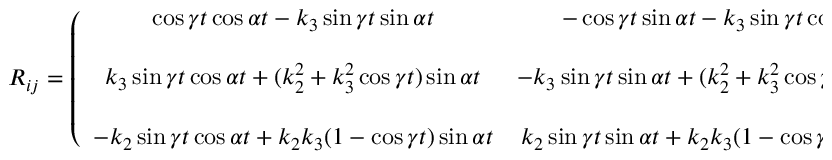<formula> <loc_0><loc_0><loc_500><loc_500>\begin{array} { r } { R _ { i j } = \left ( \begin{array} { c c c } { \cos \gamma t \cos \alpha t - k _ { 3 } \sin \gamma t \sin \alpha t } & { - \cos \gamma t \sin \alpha t - k _ { 3 } \sin \gamma t \cos \alpha t } & { k _ { 2 } \sin \gamma t } \\ { k _ { 3 } \sin \gamma t \cos \alpha t + ( k _ { 2 } ^ { 2 } + k _ { 3 } ^ { 2 } \cos \gamma t ) \sin \alpha t } & { - k _ { 3 } \sin \gamma t \sin \alpha t + ( k _ { 2 } ^ { 2 } + k _ { 3 } ^ { 2 } \cos \gamma t ) \cos \alpha t } & { k _ { 2 } k _ { 3 } ( 1 - \cos \gamma t ) } \\ { - k _ { 2 } \sin \gamma t \cos \alpha t + k _ { 2 } k _ { 3 } ( 1 - \cos \gamma t ) \sin \alpha t } & { k _ { 2 } \sin \gamma t \sin \alpha t + k _ { 2 } k _ { 3 } ( 1 - \cos \gamma t ) \cos \alpha t } & { k _ { 3 } ^ { 2 } + k _ { 2 } ^ { 2 } \cos \gamma t } \end{array} \right ) } \end{array}</formula> 